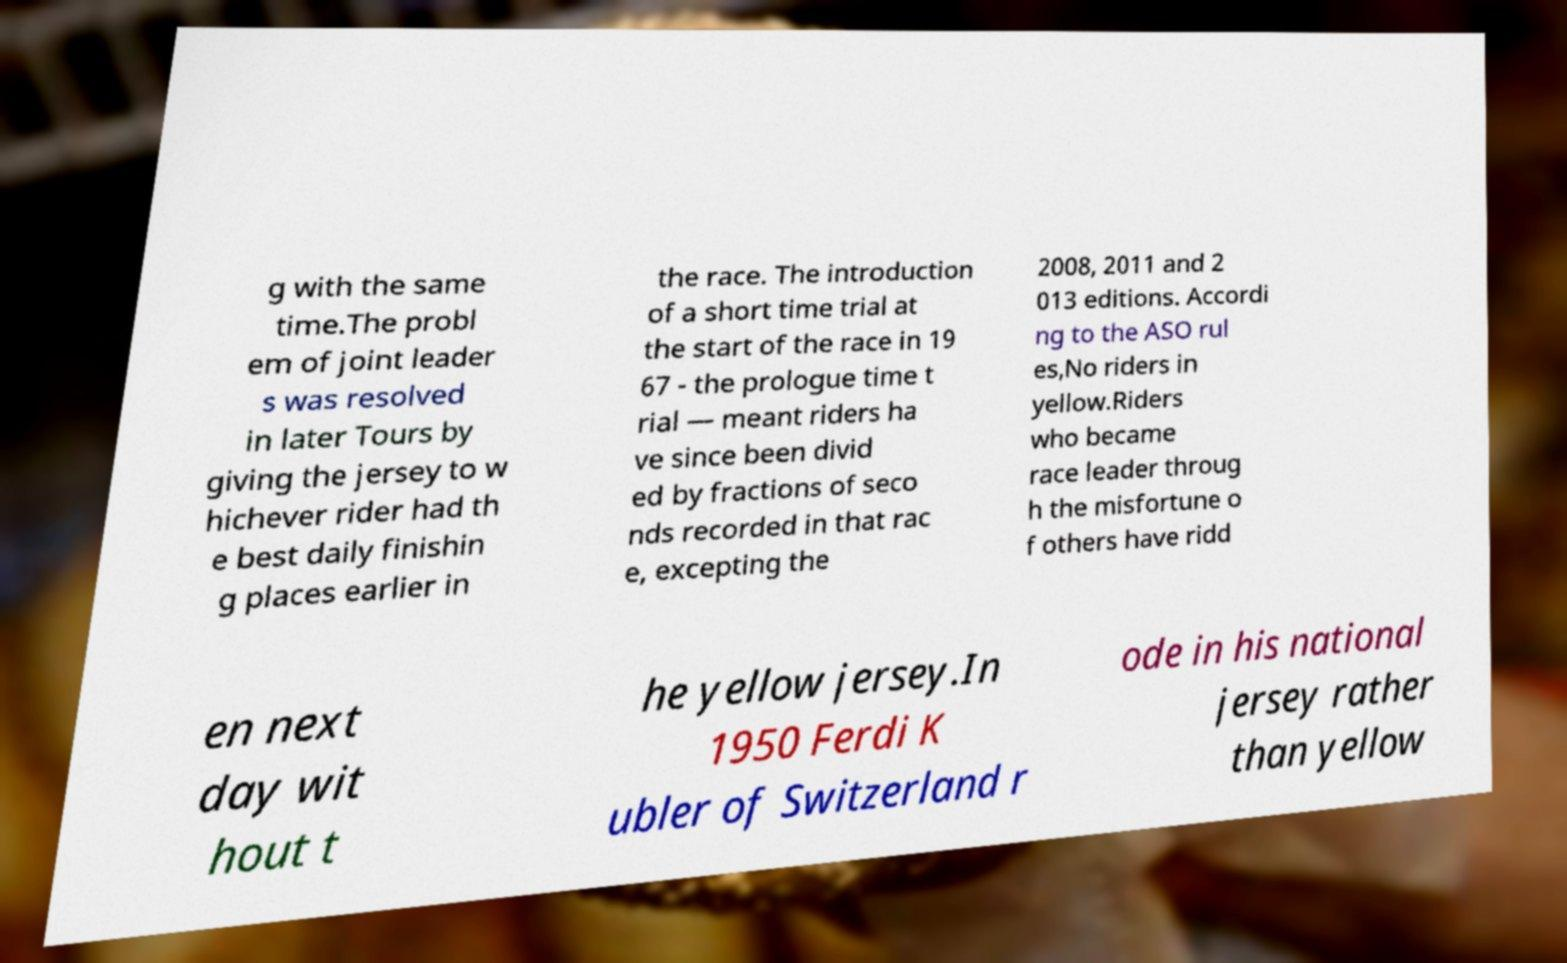What messages or text are displayed in this image? I need them in a readable, typed format. g with the same time.The probl em of joint leader s was resolved in later Tours by giving the jersey to w hichever rider had th e best daily finishin g places earlier in the race. The introduction of a short time trial at the start of the race in 19 67 - the prologue time t rial — meant riders ha ve since been divid ed by fractions of seco nds recorded in that rac e, excepting the 2008, 2011 and 2 013 editions. Accordi ng to the ASO rul es,No riders in yellow.Riders who became race leader throug h the misfortune o f others have ridd en next day wit hout t he yellow jersey.In 1950 Ferdi K ubler of Switzerland r ode in his national jersey rather than yellow 